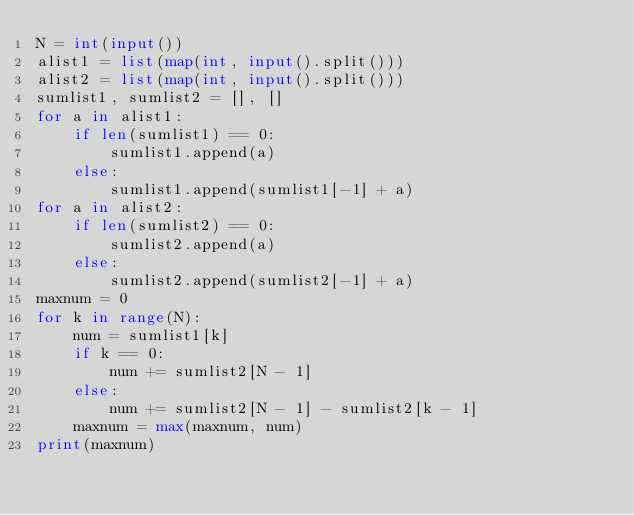Convert code to text. <code><loc_0><loc_0><loc_500><loc_500><_Python_>N = int(input())
alist1 = list(map(int, input().split()))
alist2 = list(map(int, input().split()))
sumlist1, sumlist2 = [], []
for a in alist1:
    if len(sumlist1) == 0:
        sumlist1.append(a)
    else:
        sumlist1.append(sumlist1[-1] + a)
for a in alist2:
    if len(sumlist2) == 0:
        sumlist2.append(a)
    else:
        sumlist2.append(sumlist2[-1] + a)
maxnum = 0
for k in range(N):
    num = sumlist1[k]
    if k == 0:
        num += sumlist2[N - 1]
    else:
        num += sumlist2[N - 1] - sumlist2[k - 1]
    maxnum = max(maxnum, num)
print(maxnum)</code> 